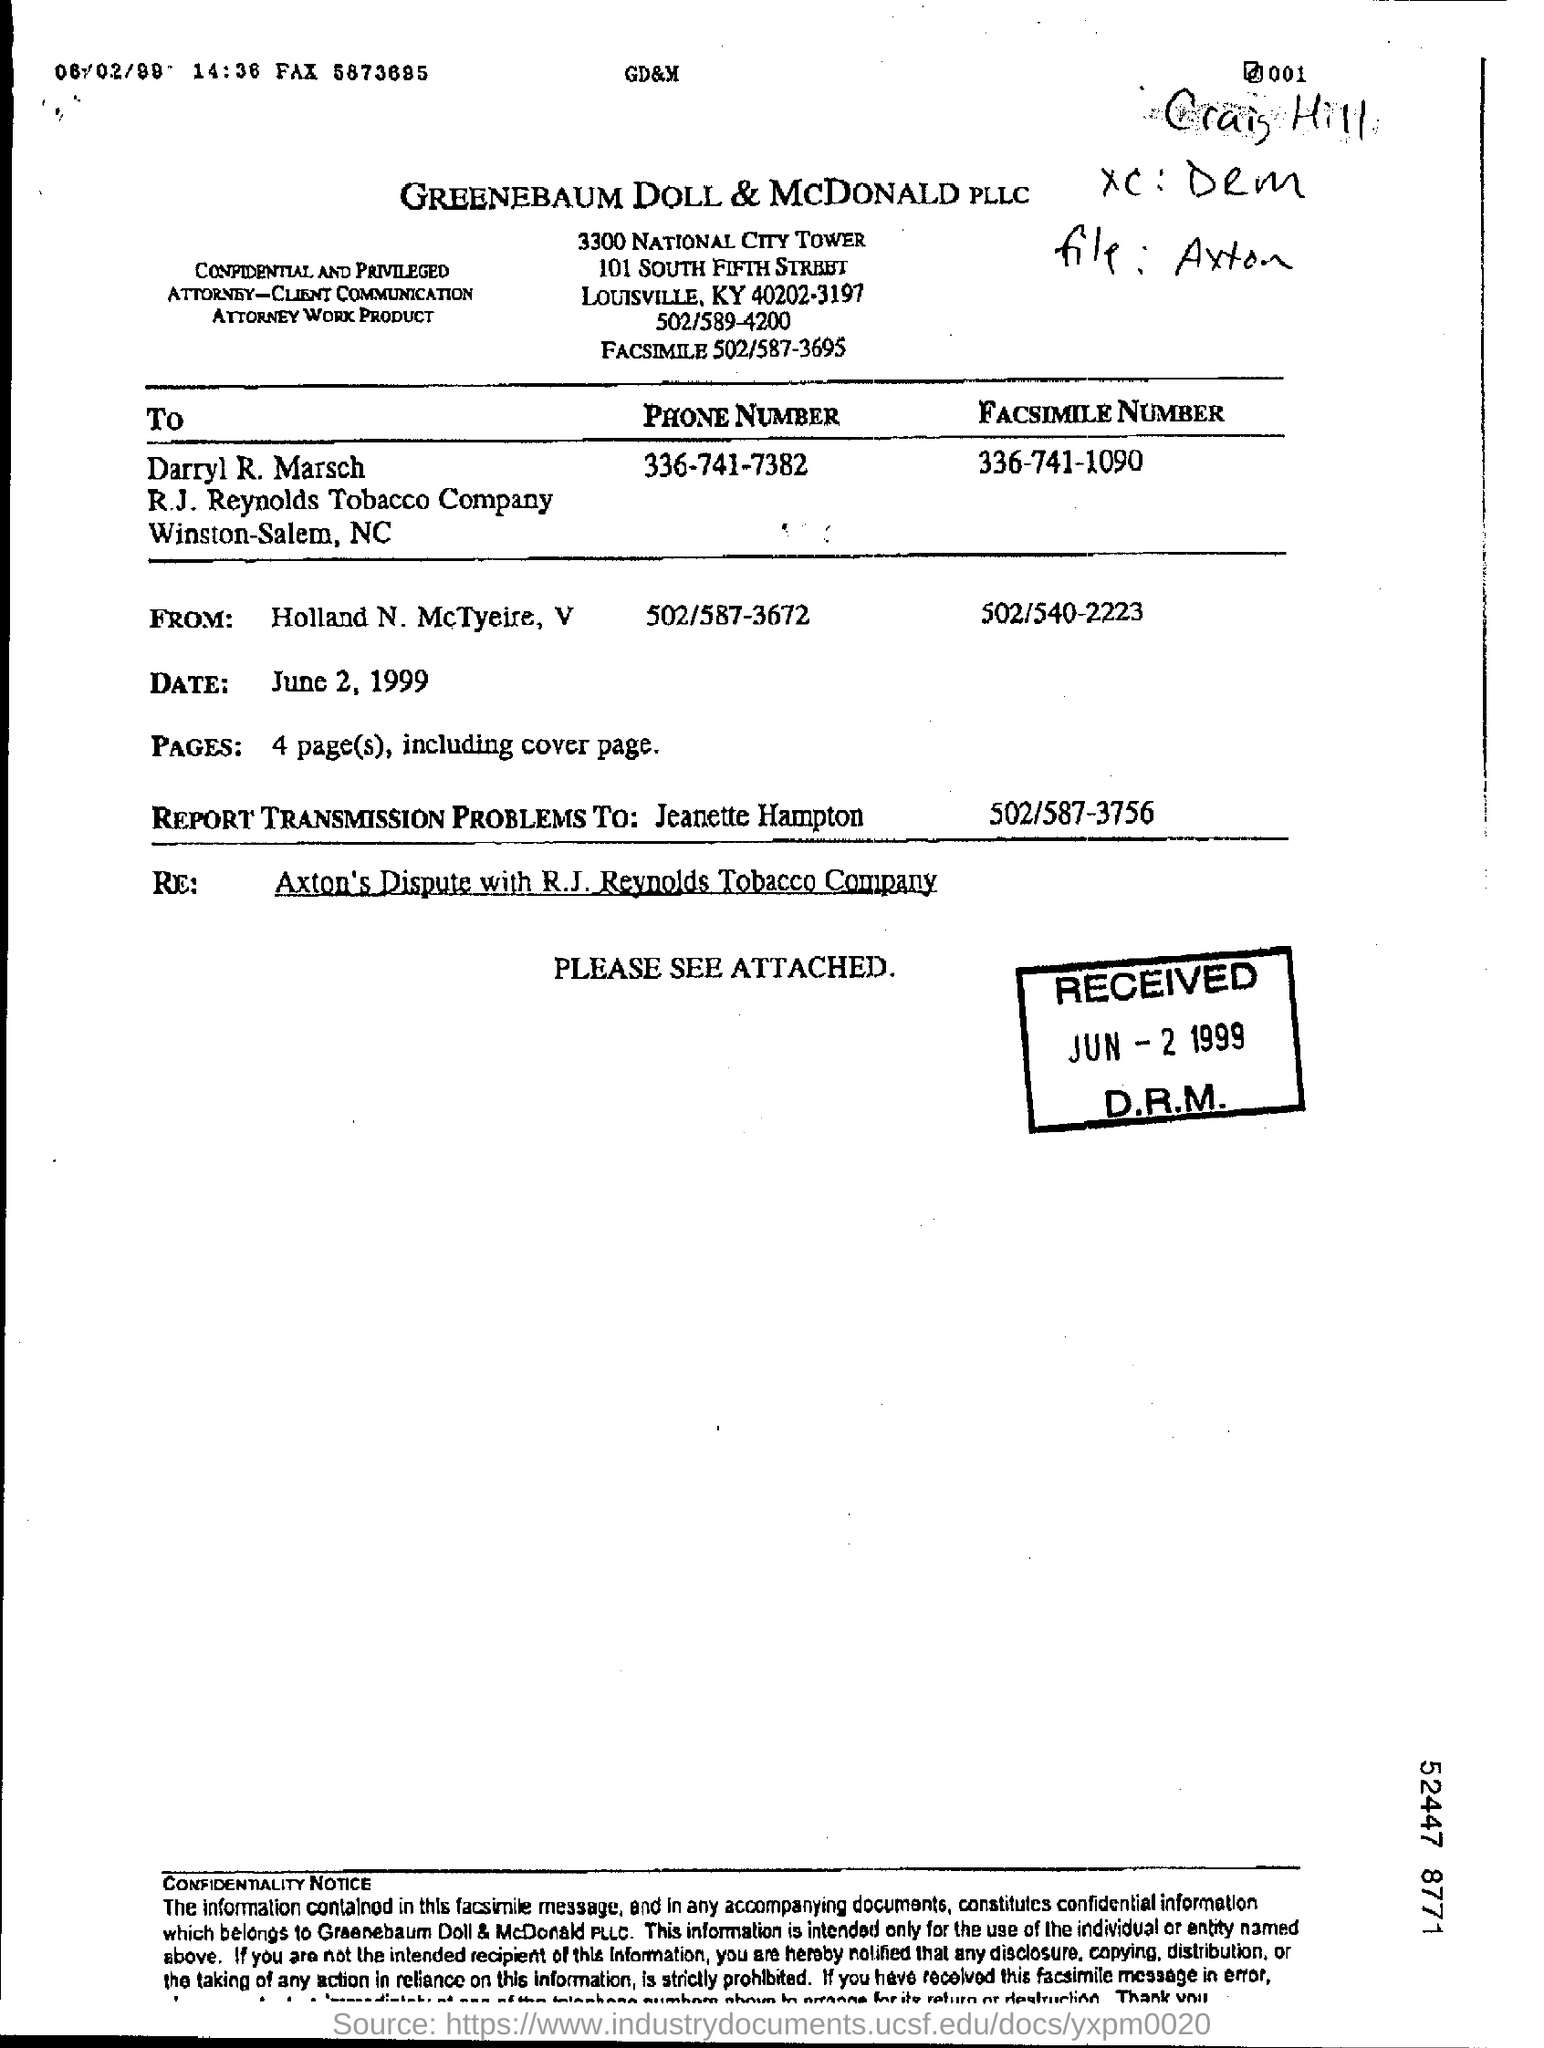Draw attention to some important aspects in this diagram. The company name on the document is GreeneBaum Doll & McDonald PLLC. 